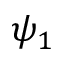Convert formula to latex. <formula><loc_0><loc_0><loc_500><loc_500>\psi _ { 1 }</formula> 